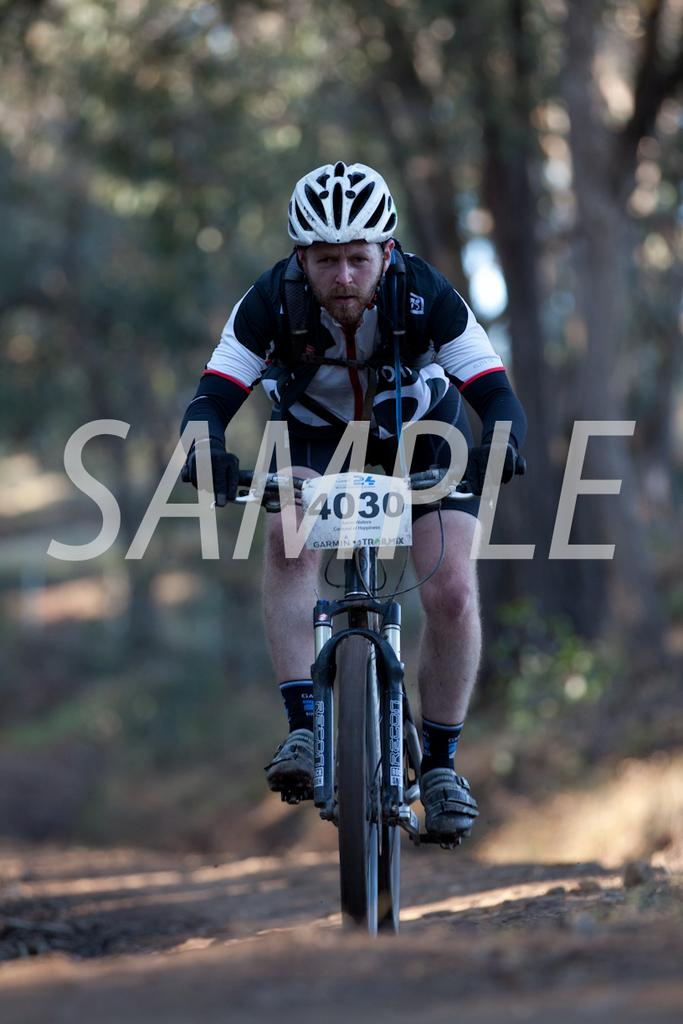Who is present in the image? There is a man in the image. What is the man doing in the image? The man is sitting on a bicycle. What can be seen in the background of the image? There are trees in the background of the image. Can you see a crown on the man's head in the image? No, there is no crown visible on the man's head in the image. 